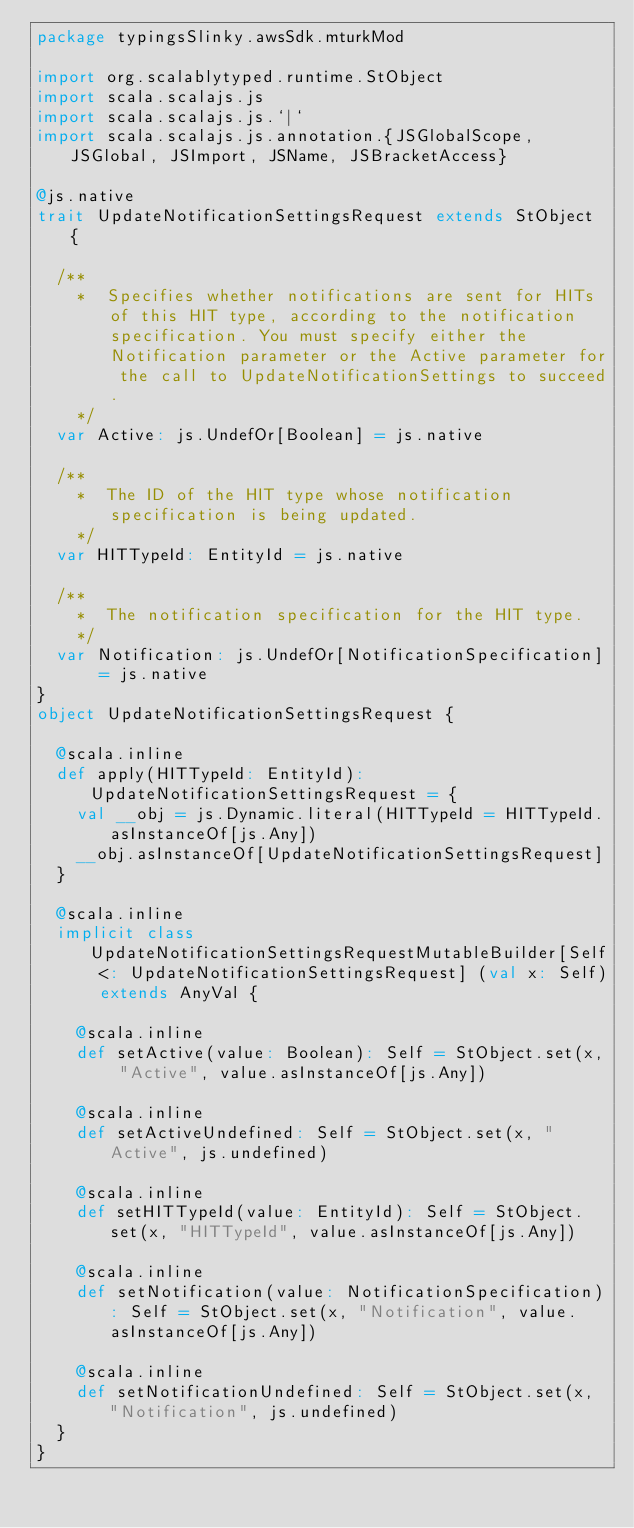Convert code to text. <code><loc_0><loc_0><loc_500><loc_500><_Scala_>package typingsSlinky.awsSdk.mturkMod

import org.scalablytyped.runtime.StObject
import scala.scalajs.js
import scala.scalajs.js.`|`
import scala.scalajs.js.annotation.{JSGlobalScope, JSGlobal, JSImport, JSName, JSBracketAccess}

@js.native
trait UpdateNotificationSettingsRequest extends StObject {
  
  /**
    *  Specifies whether notifications are sent for HITs of this HIT type, according to the notification specification. You must specify either the Notification parameter or the Active parameter for the call to UpdateNotificationSettings to succeed. 
    */
  var Active: js.UndefOr[Boolean] = js.native
  
  /**
    *  The ID of the HIT type whose notification specification is being updated. 
    */
  var HITTypeId: EntityId = js.native
  
  /**
    *  The notification specification for the HIT type. 
    */
  var Notification: js.UndefOr[NotificationSpecification] = js.native
}
object UpdateNotificationSettingsRequest {
  
  @scala.inline
  def apply(HITTypeId: EntityId): UpdateNotificationSettingsRequest = {
    val __obj = js.Dynamic.literal(HITTypeId = HITTypeId.asInstanceOf[js.Any])
    __obj.asInstanceOf[UpdateNotificationSettingsRequest]
  }
  
  @scala.inline
  implicit class UpdateNotificationSettingsRequestMutableBuilder[Self <: UpdateNotificationSettingsRequest] (val x: Self) extends AnyVal {
    
    @scala.inline
    def setActive(value: Boolean): Self = StObject.set(x, "Active", value.asInstanceOf[js.Any])
    
    @scala.inline
    def setActiveUndefined: Self = StObject.set(x, "Active", js.undefined)
    
    @scala.inline
    def setHITTypeId(value: EntityId): Self = StObject.set(x, "HITTypeId", value.asInstanceOf[js.Any])
    
    @scala.inline
    def setNotification(value: NotificationSpecification): Self = StObject.set(x, "Notification", value.asInstanceOf[js.Any])
    
    @scala.inline
    def setNotificationUndefined: Self = StObject.set(x, "Notification", js.undefined)
  }
}
</code> 